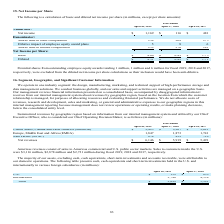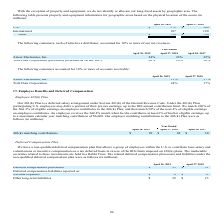From Netapp's financial document, Which years does the table provide information for property and equipment information for geographic areas based on the physical location of the assets? The document shows two values: 2019 and 2018. From the document: "April 26, 2019 April 27, 2018 April 28, 2017 April 26, 2019 April 27, 2018 April 28, 2017..." Also, What was the amount of property and equipment in U.S. in 2019? According to the financial document, 572 (in millions). The relevant text states: "U.S. $ 572 $ 566..." Also, What was the total property and equipment in 2018? According to the financial document, 756 (in millions). The relevant text states: "Total $ 759 $ 756..." Also, How many years did International property and equipment exceed $150 million? Counting the relevant items in the document: 2019, 2018, I find 2 instances. The key data points involved are: 2018, 2019. Also, can you calculate: What was the change in U.S. property and equipment between 2018 and 2019? Based on the calculation: 572-566, the result is 6 (in millions). This is based on the information: "U.S. $ 572 $ 566 U.S. $ 572 $ 566..." The key data points involved are: 566, 572. Also, can you calculate: What was the percentage change in the total amount of property and equipment between 2018 and 2019? To answer this question, I need to perform calculations using the financial data. The calculation is: (759-756)/756, which equals 0.4 (percentage). This is based on the information: "Total $ 759 $ 756 Total $ 759 $ 756..." The key data points involved are: 756, 759. 